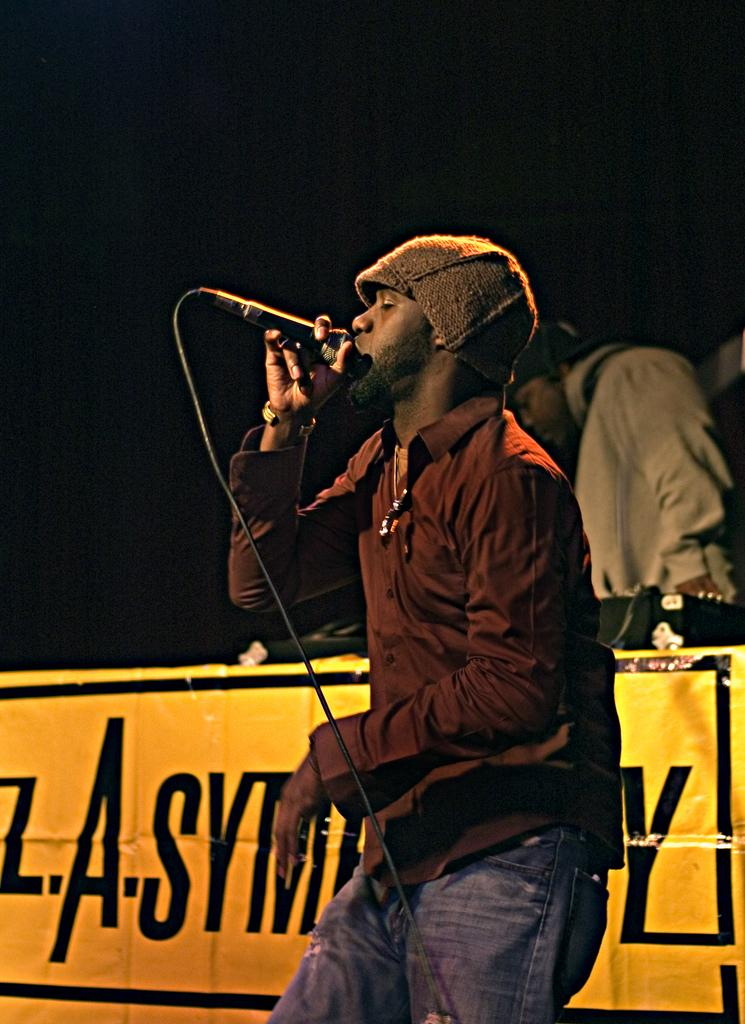What is the man in the image doing? The man is singing in the image. What object is the man holding while singing? The man is holding a microphone. Are there other people present in the image? Yes, there are people in the image. What can be seen hanging in the background? There is a banner in the image. What type of twig is the man using to play the guitar in the image? There is no guitar or twig present in the image; the man is holding a microphone while singing. 